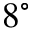Convert formula to latex. <formula><loc_0><loc_0><loc_500><loc_500>8 ^ { \circ }</formula> 